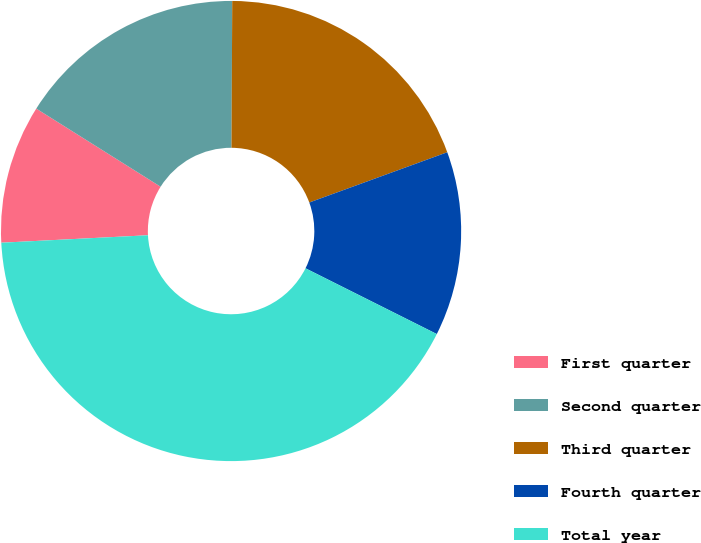Convert chart to OTSL. <chart><loc_0><loc_0><loc_500><loc_500><pie_chart><fcel>First quarter<fcel>Second quarter<fcel>Third quarter<fcel>Fourth quarter<fcel>Total year<nl><fcel>9.74%<fcel>16.15%<fcel>19.36%<fcel>12.95%<fcel>41.8%<nl></chart> 